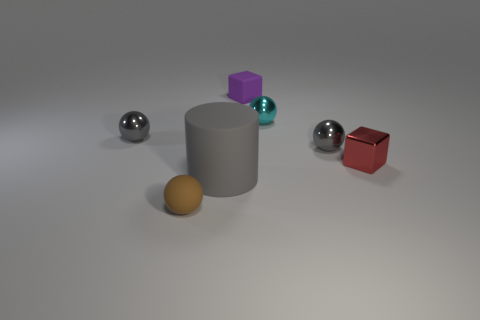Are there any other things that have the same size as the rubber cylinder?
Make the answer very short. No. How big is the gray sphere that is to the right of the purple block?
Provide a succinct answer. Small. What number of things are either large red cylinders or things to the right of the big object?
Offer a very short reply. 4. How many other things are the same size as the brown thing?
Your response must be concise. 5. What is the material of the small brown thing that is the same shape as the cyan thing?
Your answer should be compact. Rubber. Is the number of big rubber cylinders that are right of the gray matte cylinder greater than the number of large gray rubber objects?
Your answer should be compact. No. Is there anything else that has the same color as the tiny rubber cube?
Your answer should be very brief. No. What is the shape of the brown object that is the same material as the gray cylinder?
Your answer should be compact. Sphere. Is the material of the tiny gray sphere to the left of the small brown ball the same as the red thing?
Offer a terse response. Yes. Do the metallic object on the left side of the tiny brown rubber sphere and the small rubber object behind the cyan object have the same color?
Keep it short and to the point. No. 